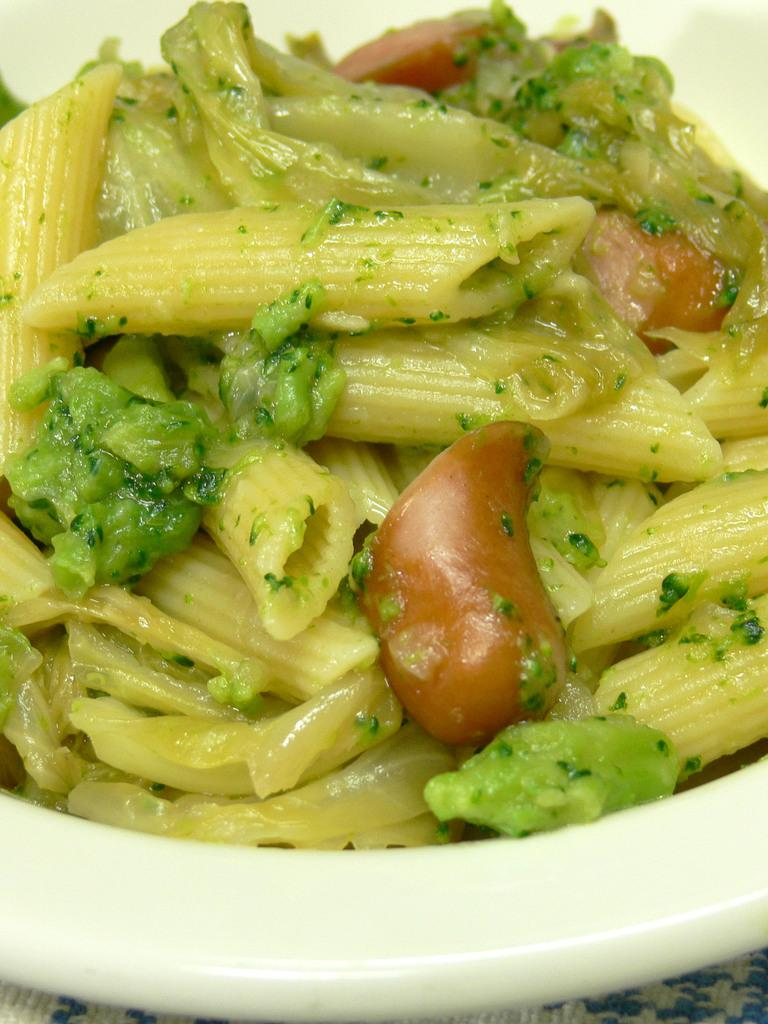What is the main subject of the image? There is a food item in the image. How is the food item presented? The food item is on a plate. Is the plate placed on any surface? Yes, the plate is on a platform. What type of zebra can be seen using a hammer to break the dinner plate in the image? There is no zebra or hammer present in the image, and no dinner plate is being broken. 